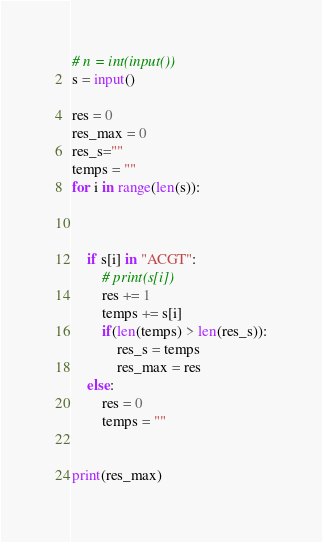<code> <loc_0><loc_0><loc_500><loc_500><_Python_># n = int(input())
s = input()

res = 0
res_max = 0
res_s=""
temps = ""
for i in range(len(s)):



    if s[i] in "ACGT":
        # print(s[i])
        res += 1
        temps += s[i]
        if(len(temps) > len(res_s)):
            res_s = temps
            res_max = res
    else:
        res = 0
        temps = ""


print(res_max)</code> 